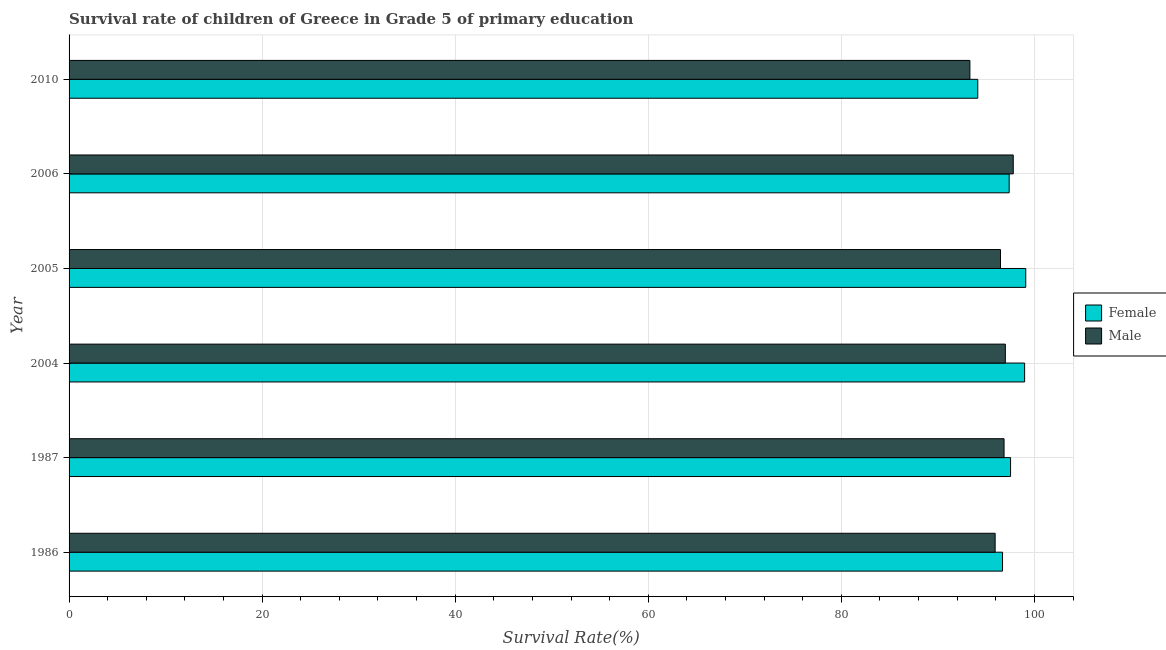How many different coloured bars are there?
Make the answer very short. 2. Are the number of bars per tick equal to the number of legend labels?
Keep it short and to the point. Yes. Are the number of bars on each tick of the Y-axis equal?
Your answer should be very brief. Yes. What is the survival rate of female students in primary education in 2005?
Keep it short and to the point. 99.1. Across all years, what is the maximum survival rate of female students in primary education?
Make the answer very short. 99.1. Across all years, what is the minimum survival rate of male students in primary education?
Offer a terse response. 93.32. In which year was the survival rate of female students in primary education maximum?
Offer a terse response. 2005. In which year was the survival rate of male students in primary education minimum?
Your answer should be very brief. 2010. What is the total survival rate of female students in primary education in the graph?
Give a very brief answer. 583.84. What is the difference between the survival rate of male students in primary education in 2005 and that in 2010?
Provide a short and direct response. 3.17. What is the difference between the survival rate of male students in primary education in 2006 and the survival rate of female students in primary education in 2004?
Ensure brevity in your answer.  -1.18. What is the average survival rate of male students in primary education per year?
Give a very brief answer. 96.23. In the year 2004, what is the difference between the survival rate of female students in primary education and survival rate of male students in primary education?
Your answer should be very brief. 2. In how many years, is the survival rate of male students in primary education greater than 4 %?
Your response must be concise. 6. What is the ratio of the survival rate of male students in primary education in 2005 to that in 2010?
Your answer should be compact. 1.03. What is the difference between the highest and the second highest survival rate of male students in primary education?
Give a very brief answer. 0.82. What is the difference between the highest and the lowest survival rate of female students in primary education?
Make the answer very short. 4.97. What does the 2nd bar from the bottom in 1986 represents?
Provide a succinct answer. Male. Are all the bars in the graph horizontal?
Your response must be concise. Yes. How many years are there in the graph?
Ensure brevity in your answer.  6. Does the graph contain any zero values?
Ensure brevity in your answer.  No. Where does the legend appear in the graph?
Provide a succinct answer. Center right. How many legend labels are there?
Provide a succinct answer. 2. How are the legend labels stacked?
Offer a very short reply. Vertical. What is the title of the graph?
Provide a succinct answer. Survival rate of children of Greece in Grade 5 of primary education. What is the label or title of the X-axis?
Your answer should be very brief. Survival Rate(%). What is the Survival Rate(%) in Female in 1986?
Keep it short and to the point. 96.7. What is the Survival Rate(%) of Male in 1986?
Offer a very short reply. 95.93. What is the Survival Rate(%) in Female in 1987?
Offer a very short reply. 97.53. What is the Survival Rate(%) of Male in 1987?
Provide a short and direct response. 96.86. What is the Survival Rate(%) of Female in 2004?
Provide a short and direct response. 98.99. What is the Survival Rate(%) in Male in 2004?
Your response must be concise. 96.99. What is the Survival Rate(%) in Female in 2005?
Ensure brevity in your answer.  99.1. What is the Survival Rate(%) in Male in 2005?
Offer a terse response. 96.49. What is the Survival Rate(%) in Female in 2006?
Your response must be concise. 97.39. What is the Survival Rate(%) in Male in 2006?
Provide a short and direct response. 97.81. What is the Survival Rate(%) in Female in 2010?
Your answer should be very brief. 94.13. What is the Survival Rate(%) in Male in 2010?
Provide a succinct answer. 93.32. Across all years, what is the maximum Survival Rate(%) of Female?
Offer a terse response. 99.1. Across all years, what is the maximum Survival Rate(%) in Male?
Ensure brevity in your answer.  97.81. Across all years, what is the minimum Survival Rate(%) of Female?
Provide a short and direct response. 94.13. Across all years, what is the minimum Survival Rate(%) in Male?
Ensure brevity in your answer.  93.32. What is the total Survival Rate(%) of Female in the graph?
Provide a short and direct response. 583.84. What is the total Survival Rate(%) in Male in the graph?
Make the answer very short. 577.39. What is the difference between the Survival Rate(%) in Female in 1986 and that in 1987?
Give a very brief answer. -0.83. What is the difference between the Survival Rate(%) in Male in 1986 and that in 1987?
Give a very brief answer. -0.92. What is the difference between the Survival Rate(%) of Female in 1986 and that in 2004?
Offer a terse response. -2.29. What is the difference between the Survival Rate(%) in Male in 1986 and that in 2004?
Your response must be concise. -1.06. What is the difference between the Survival Rate(%) of Female in 1986 and that in 2005?
Make the answer very short. -2.41. What is the difference between the Survival Rate(%) in Male in 1986 and that in 2005?
Give a very brief answer. -0.56. What is the difference between the Survival Rate(%) of Female in 1986 and that in 2006?
Provide a short and direct response. -0.69. What is the difference between the Survival Rate(%) in Male in 1986 and that in 2006?
Your answer should be very brief. -1.88. What is the difference between the Survival Rate(%) in Female in 1986 and that in 2010?
Provide a succinct answer. 2.57. What is the difference between the Survival Rate(%) of Male in 1986 and that in 2010?
Offer a very short reply. 2.61. What is the difference between the Survival Rate(%) of Female in 1987 and that in 2004?
Your answer should be compact. -1.46. What is the difference between the Survival Rate(%) of Male in 1987 and that in 2004?
Offer a terse response. -0.13. What is the difference between the Survival Rate(%) in Female in 1987 and that in 2005?
Your response must be concise. -1.57. What is the difference between the Survival Rate(%) of Male in 1987 and that in 2005?
Your answer should be compact. 0.37. What is the difference between the Survival Rate(%) of Female in 1987 and that in 2006?
Your response must be concise. 0.14. What is the difference between the Survival Rate(%) of Male in 1987 and that in 2006?
Keep it short and to the point. -0.95. What is the difference between the Survival Rate(%) of Female in 1987 and that in 2010?
Your answer should be compact. 3.4. What is the difference between the Survival Rate(%) in Male in 1987 and that in 2010?
Offer a very short reply. 3.54. What is the difference between the Survival Rate(%) of Female in 2004 and that in 2005?
Make the answer very short. -0.12. What is the difference between the Survival Rate(%) in Male in 2004 and that in 2005?
Your response must be concise. 0.5. What is the difference between the Survival Rate(%) of Female in 2004 and that in 2006?
Your answer should be compact. 1.6. What is the difference between the Survival Rate(%) in Male in 2004 and that in 2006?
Keep it short and to the point. -0.82. What is the difference between the Survival Rate(%) in Female in 2004 and that in 2010?
Make the answer very short. 4.85. What is the difference between the Survival Rate(%) of Male in 2004 and that in 2010?
Provide a succinct answer. 3.67. What is the difference between the Survival Rate(%) of Female in 2005 and that in 2006?
Offer a terse response. 1.72. What is the difference between the Survival Rate(%) in Male in 2005 and that in 2006?
Provide a succinct answer. -1.32. What is the difference between the Survival Rate(%) of Female in 2005 and that in 2010?
Give a very brief answer. 4.97. What is the difference between the Survival Rate(%) in Male in 2005 and that in 2010?
Your answer should be very brief. 3.17. What is the difference between the Survival Rate(%) of Female in 2006 and that in 2010?
Provide a short and direct response. 3.25. What is the difference between the Survival Rate(%) of Male in 2006 and that in 2010?
Offer a terse response. 4.49. What is the difference between the Survival Rate(%) of Female in 1986 and the Survival Rate(%) of Male in 1987?
Provide a succinct answer. -0.16. What is the difference between the Survival Rate(%) in Female in 1986 and the Survival Rate(%) in Male in 2004?
Your answer should be very brief. -0.29. What is the difference between the Survival Rate(%) in Female in 1986 and the Survival Rate(%) in Male in 2005?
Your response must be concise. 0.21. What is the difference between the Survival Rate(%) in Female in 1986 and the Survival Rate(%) in Male in 2006?
Offer a terse response. -1.11. What is the difference between the Survival Rate(%) in Female in 1986 and the Survival Rate(%) in Male in 2010?
Your answer should be compact. 3.38. What is the difference between the Survival Rate(%) of Female in 1987 and the Survival Rate(%) of Male in 2004?
Offer a terse response. 0.54. What is the difference between the Survival Rate(%) in Female in 1987 and the Survival Rate(%) in Male in 2005?
Give a very brief answer. 1.04. What is the difference between the Survival Rate(%) in Female in 1987 and the Survival Rate(%) in Male in 2006?
Give a very brief answer. -0.28. What is the difference between the Survival Rate(%) in Female in 1987 and the Survival Rate(%) in Male in 2010?
Give a very brief answer. 4.21. What is the difference between the Survival Rate(%) in Female in 2004 and the Survival Rate(%) in Male in 2005?
Provide a succinct answer. 2.5. What is the difference between the Survival Rate(%) of Female in 2004 and the Survival Rate(%) of Male in 2006?
Give a very brief answer. 1.18. What is the difference between the Survival Rate(%) in Female in 2004 and the Survival Rate(%) in Male in 2010?
Offer a terse response. 5.67. What is the difference between the Survival Rate(%) of Female in 2005 and the Survival Rate(%) of Male in 2006?
Your response must be concise. 1.3. What is the difference between the Survival Rate(%) of Female in 2005 and the Survival Rate(%) of Male in 2010?
Your answer should be compact. 5.79. What is the difference between the Survival Rate(%) in Female in 2006 and the Survival Rate(%) in Male in 2010?
Provide a succinct answer. 4.07. What is the average Survival Rate(%) in Female per year?
Make the answer very short. 97.31. What is the average Survival Rate(%) of Male per year?
Provide a short and direct response. 96.23. In the year 1986, what is the difference between the Survival Rate(%) in Female and Survival Rate(%) in Male?
Keep it short and to the point. 0.77. In the year 1987, what is the difference between the Survival Rate(%) in Female and Survival Rate(%) in Male?
Provide a short and direct response. 0.67. In the year 2004, what is the difference between the Survival Rate(%) in Female and Survival Rate(%) in Male?
Offer a very short reply. 2. In the year 2005, what is the difference between the Survival Rate(%) of Female and Survival Rate(%) of Male?
Offer a very short reply. 2.62. In the year 2006, what is the difference between the Survival Rate(%) in Female and Survival Rate(%) in Male?
Keep it short and to the point. -0.42. In the year 2010, what is the difference between the Survival Rate(%) in Female and Survival Rate(%) in Male?
Make the answer very short. 0.82. What is the ratio of the Survival Rate(%) in Male in 1986 to that in 1987?
Offer a terse response. 0.99. What is the ratio of the Survival Rate(%) of Female in 1986 to that in 2004?
Your answer should be compact. 0.98. What is the ratio of the Survival Rate(%) in Female in 1986 to that in 2005?
Offer a terse response. 0.98. What is the ratio of the Survival Rate(%) of Female in 1986 to that in 2006?
Your answer should be very brief. 0.99. What is the ratio of the Survival Rate(%) in Male in 1986 to that in 2006?
Your response must be concise. 0.98. What is the ratio of the Survival Rate(%) in Female in 1986 to that in 2010?
Give a very brief answer. 1.03. What is the ratio of the Survival Rate(%) of Male in 1986 to that in 2010?
Provide a succinct answer. 1.03. What is the ratio of the Survival Rate(%) of Female in 1987 to that in 2004?
Make the answer very short. 0.99. What is the ratio of the Survival Rate(%) in Male in 1987 to that in 2004?
Your answer should be very brief. 1. What is the ratio of the Survival Rate(%) of Female in 1987 to that in 2005?
Your response must be concise. 0.98. What is the ratio of the Survival Rate(%) of Male in 1987 to that in 2005?
Give a very brief answer. 1. What is the ratio of the Survival Rate(%) in Male in 1987 to that in 2006?
Offer a very short reply. 0.99. What is the ratio of the Survival Rate(%) of Female in 1987 to that in 2010?
Keep it short and to the point. 1.04. What is the ratio of the Survival Rate(%) in Male in 1987 to that in 2010?
Offer a very short reply. 1.04. What is the ratio of the Survival Rate(%) of Female in 2004 to that in 2005?
Provide a succinct answer. 1. What is the ratio of the Survival Rate(%) in Female in 2004 to that in 2006?
Your answer should be compact. 1.02. What is the ratio of the Survival Rate(%) in Male in 2004 to that in 2006?
Offer a terse response. 0.99. What is the ratio of the Survival Rate(%) in Female in 2004 to that in 2010?
Your answer should be compact. 1.05. What is the ratio of the Survival Rate(%) in Male in 2004 to that in 2010?
Your answer should be compact. 1.04. What is the ratio of the Survival Rate(%) in Female in 2005 to that in 2006?
Your answer should be compact. 1.02. What is the ratio of the Survival Rate(%) of Male in 2005 to that in 2006?
Give a very brief answer. 0.99. What is the ratio of the Survival Rate(%) in Female in 2005 to that in 2010?
Offer a very short reply. 1.05. What is the ratio of the Survival Rate(%) in Male in 2005 to that in 2010?
Your answer should be very brief. 1.03. What is the ratio of the Survival Rate(%) of Female in 2006 to that in 2010?
Give a very brief answer. 1.03. What is the ratio of the Survival Rate(%) of Male in 2006 to that in 2010?
Provide a succinct answer. 1.05. What is the difference between the highest and the second highest Survival Rate(%) of Female?
Make the answer very short. 0.12. What is the difference between the highest and the second highest Survival Rate(%) in Male?
Your answer should be compact. 0.82. What is the difference between the highest and the lowest Survival Rate(%) in Female?
Provide a short and direct response. 4.97. What is the difference between the highest and the lowest Survival Rate(%) in Male?
Provide a succinct answer. 4.49. 